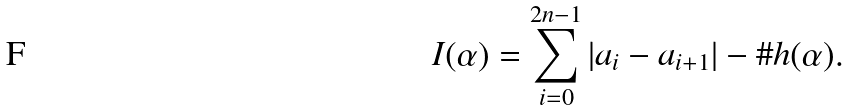<formula> <loc_0><loc_0><loc_500><loc_500>I ( \alpha ) = \sum _ { i = 0 } ^ { 2 n - 1 } \left | a _ { i } - a _ { i + 1 } \right | - \# h ( \alpha ) .</formula> 